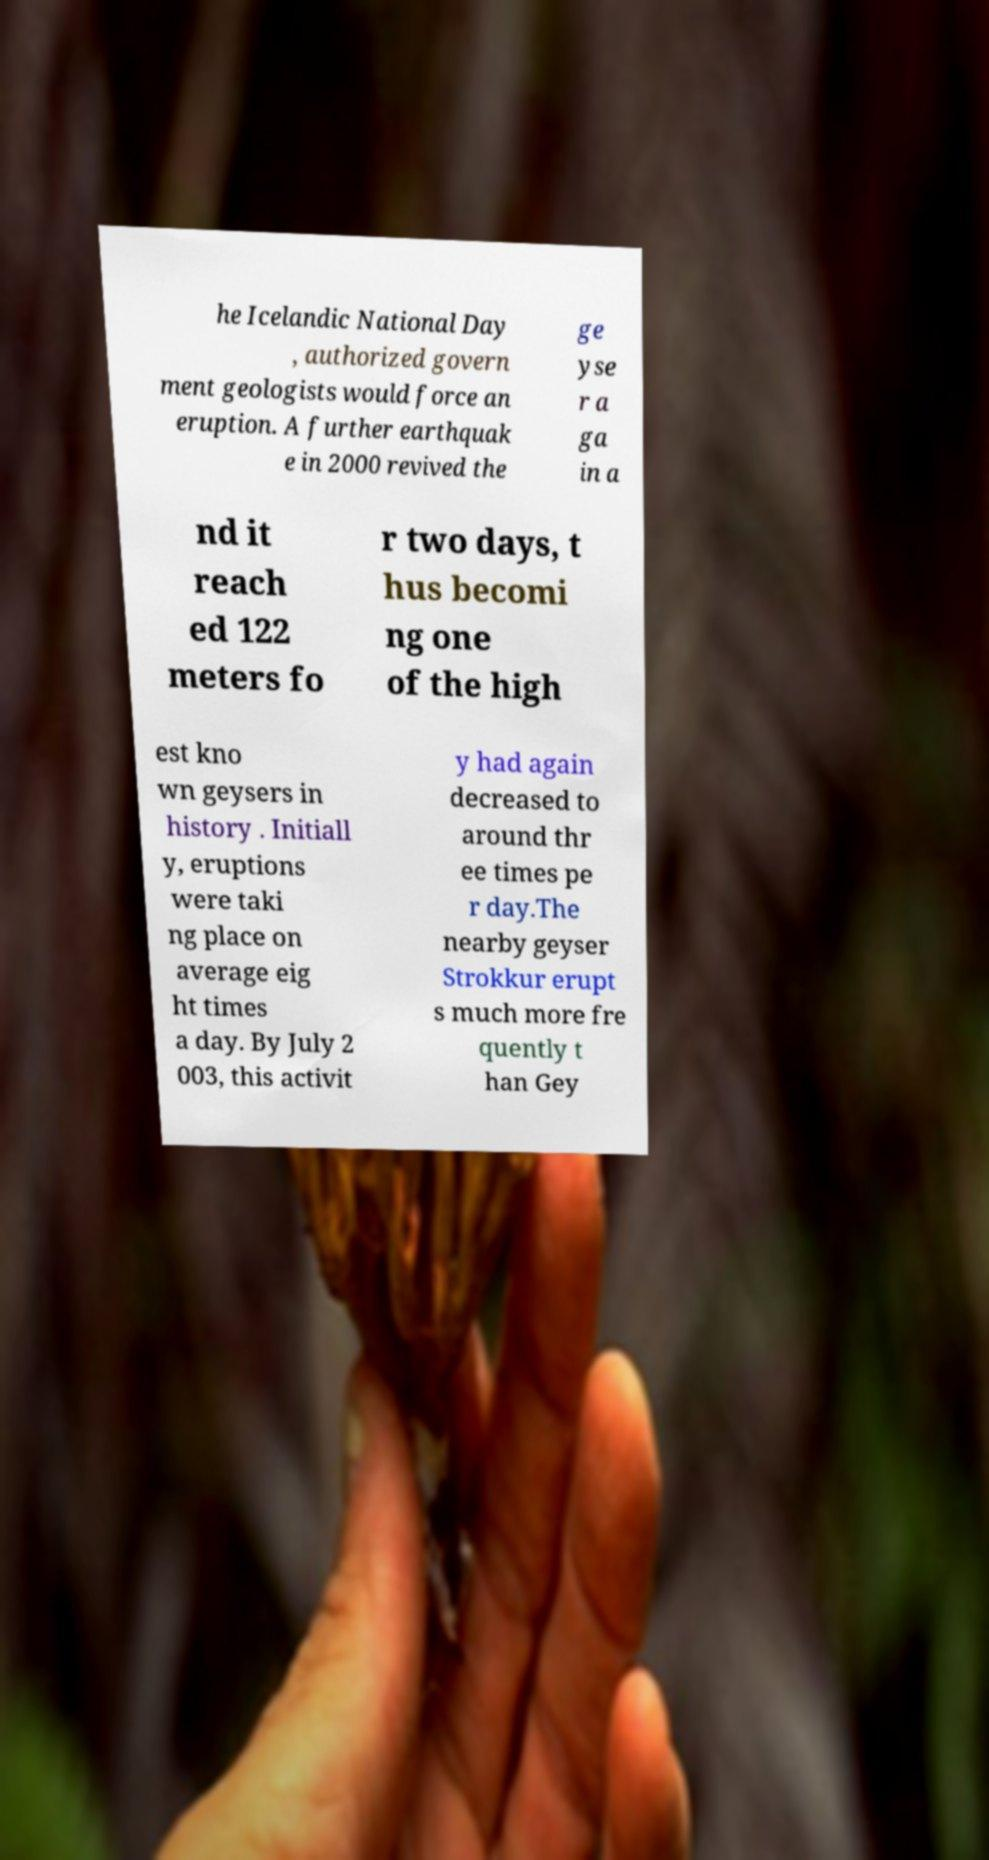Please read and relay the text visible in this image. What does it say? he Icelandic National Day , authorized govern ment geologists would force an eruption. A further earthquak e in 2000 revived the ge yse r a ga in a nd it reach ed 122 meters fo r two days, t hus becomi ng one of the high est kno wn geysers in history . Initiall y, eruptions were taki ng place on average eig ht times a day. By July 2 003, this activit y had again decreased to around thr ee times pe r day.The nearby geyser Strokkur erupt s much more fre quently t han Gey 